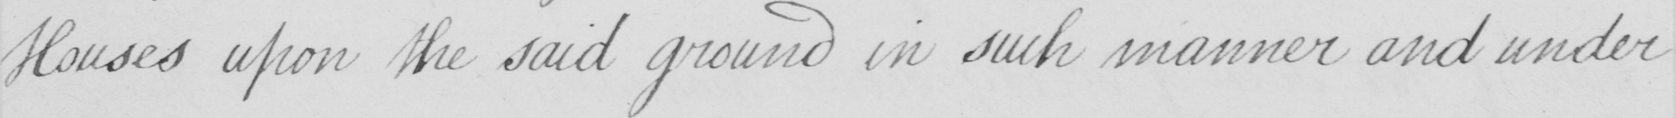Transcribe the text shown in this historical manuscript line. Houses upon the said ground in such manner and under 